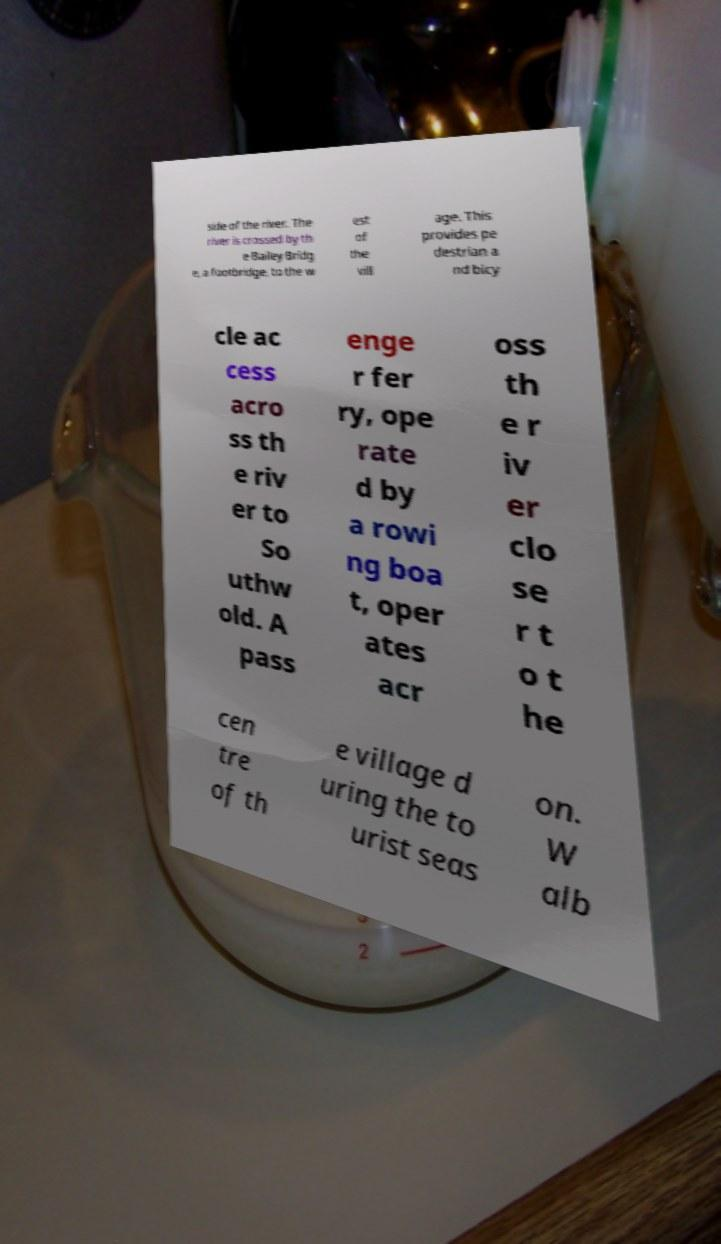Can you read and provide the text displayed in the image?This photo seems to have some interesting text. Can you extract and type it out for me? side of the river. The river is crossed by th e Bailey Bridg e, a footbridge, to the w est of the vill age. This provides pe destrian a nd bicy cle ac cess acro ss th e riv er to So uthw old. A pass enge r fer ry, ope rate d by a rowi ng boa t, oper ates acr oss th e r iv er clo se r t o t he cen tre of th e village d uring the to urist seas on. W alb 